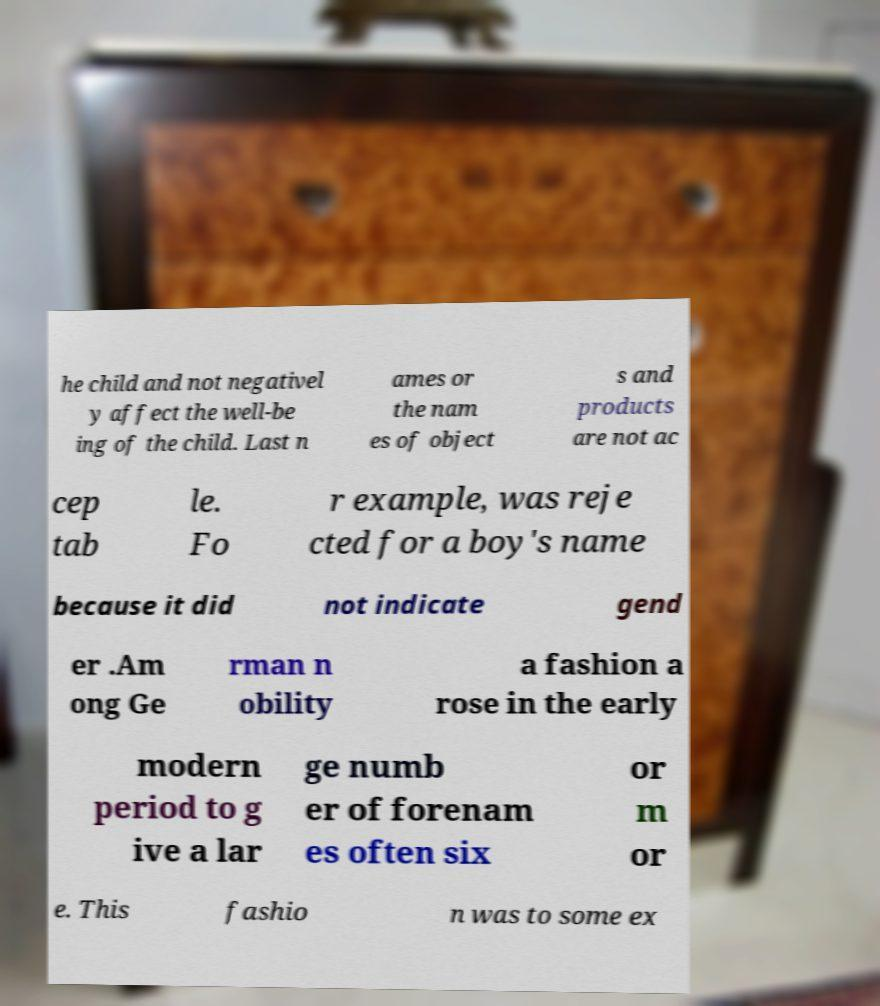What messages or text are displayed in this image? I need them in a readable, typed format. he child and not negativel y affect the well-be ing of the child. Last n ames or the nam es of object s and products are not ac cep tab le. Fo r example, was reje cted for a boy's name because it did not indicate gend er .Am ong Ge rman n obility a fashion a rose in the early modern period to g ive a lar ge numb er of forenam es often six or m or e. This fashio n was to some ex 